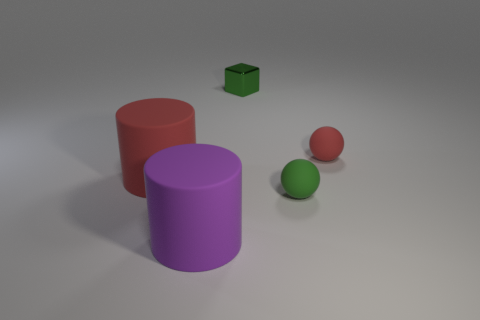Add 3 rubber cylinders. How many objects exist? 8 Subtract all cylinders. How many objects are left? 3 Subtract 0 brown cylinders. How many objects are left? 5 Subtract all red matte things. Subtract all big purple matte objects. How many objects are left? 2 Add 4 large cylinders. How many large cylinders are left? 6 Add 4 small yellow metal things. How many small yellow metal things exist? 4 